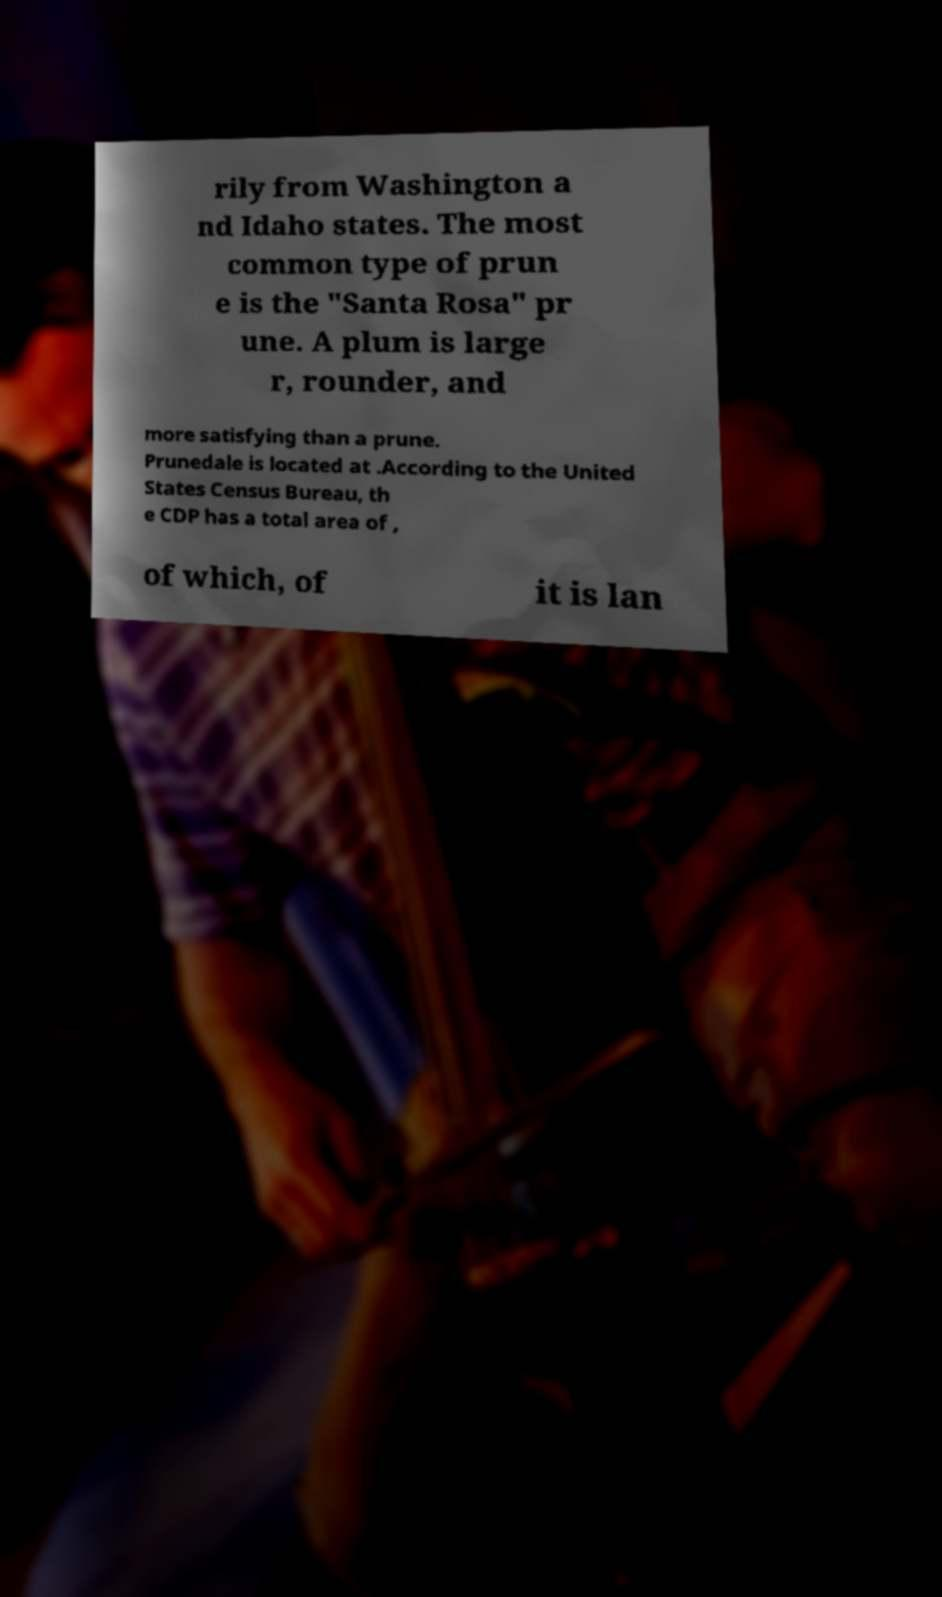Could you extract and type out the text from this image? rily from Washington a nd Idaho states. The most common type of prun e is the "Santa Rosa" pr une. A plum is large r, rounder, and more satisfying than a prune. Prunedale is located at .According to the United States Census Bureau, th e CDP has a total area of , of which, of it is lan 